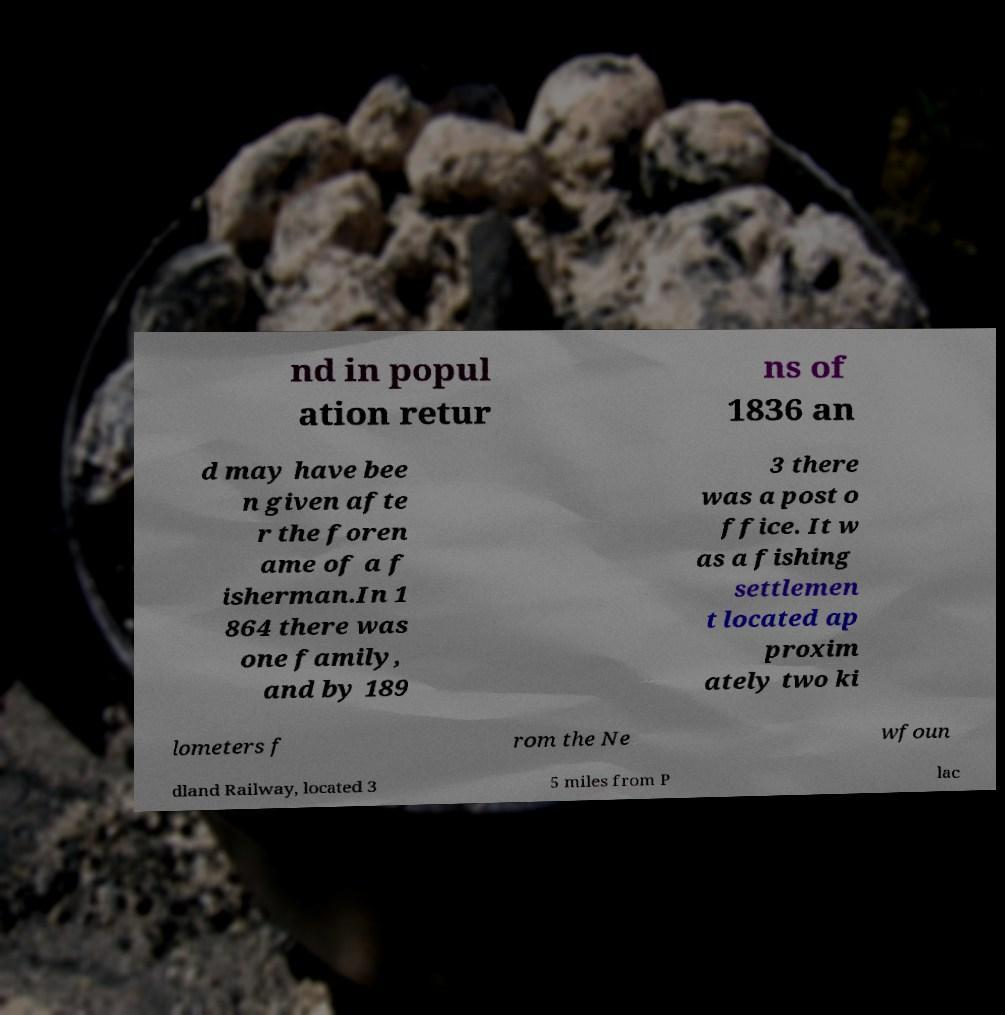I need the written content from this picture converted into text. Can you do that? nd in popul ation retur ns of 1836 an d may have bee n given afte r the foren ame of a f isherman.In 1 864 there was one family, and by 189 3 there was a post o ffice. It w as a fishing settlemen t located ap proxim ately two ki lometers f rom the Ne wfoun dland Railway, located 3 5 miles from P lac 